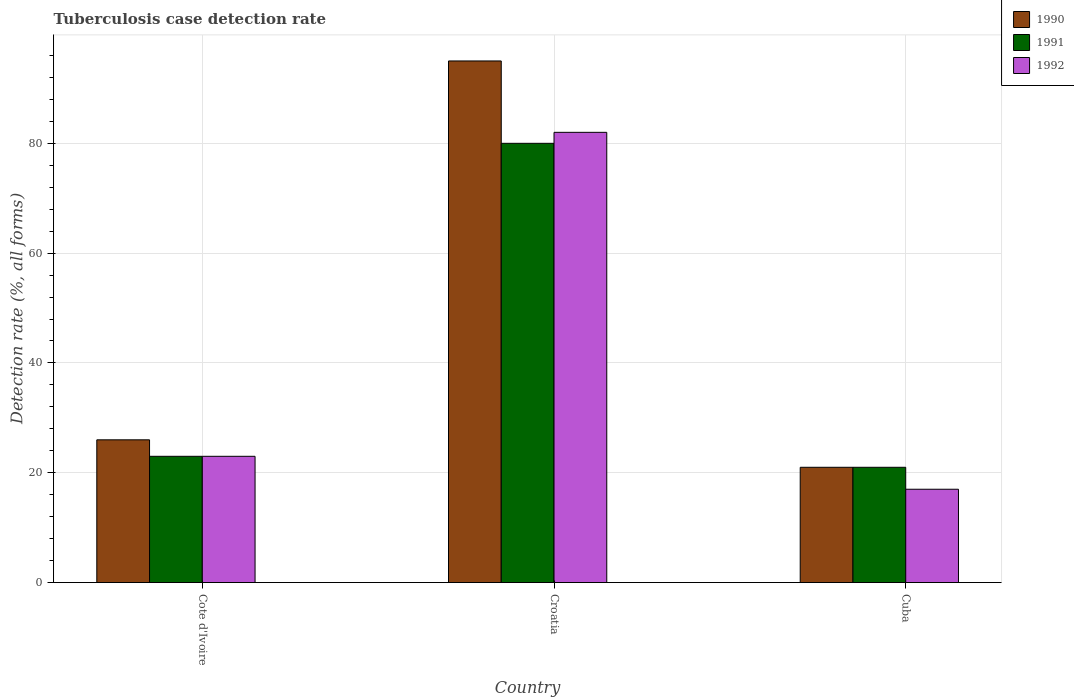How many different coloured bars are there?
Give a very brief answer. 3. How many groups of bars are there?
Your response must be concise. 3. Are the number of bars per tick equal to the number of legend labels?
Keep it short and to the point. Yes. How many bars are there on the 3rd tick from the right?
Ensure brevity in your answer.  3. What is the label of the 3rd group of bars from the left?
Make the answer very short. Cuba. Across all countries, what is the maximum tuberculosis case detection rate in in 1990?
Provide a short and direct response. 95. Across all countries, what is the minimum tuberculosis case detection rate in in 1990?
Offer a terse response. 21. In which country was the tuberculosis case detection rate in in 1992 maximum?
Give a very brief answer. Croatia. In which country was the tuberculosis case detection rate in in 1990 minimum?
Ensure brevity in your answer.  Cuba. What is the total tuberculosis case detection rate in in 1992 in the graph?
Give a very brief answer. 122. What is the average tuberculosis case detection rate in in 1992 per country?
Ensure brevity in your answer.  40.67. What is the difference between the tuberculosis case detection rate in of/in 1990 and tuberculosis case detection rate in of/in 1992 in Cuba?
Give a very brief answer. 4. In how many countries, is the tuberculosis case detection rate in in 1992 greater than 68 %?
Make the answer very short. 1. What is the ratio of the tuberculosis case detection rate in in 1991 in Cote d'Ivoire to that in Cuba?
Make the answer very short. 1.1. Is the tuberculosis case detection rate in in 1990 in Cote d'Ivoire less than that in Cuba?
Ensure brevity in your answer.  No. Is the difference between the tuberculosis case detection rate in in 1990 in Cote d'Ivoire and Cuba greater than the difference between the tuberculosis case detection rate in in 1992 in Cote d'Ivoire and Cuba?
Your answer should be very brief. No. What is the difference between the highest and the second highest tuberculosis case detection rate in in 1991?
Offer a very short reply. 59. In how many countries, is the tuberculosis case detection rate in in 1991 greater than the average tuberculosis case detection rate in in 1991 taken over all countries?
Give a very brief answer. 1. What does the 1st bar from the left in Cuba represents?
Keep it short and to the point. 1990. Are all the bars in the graph horizontal?
Provide a short and direct response. No. Does the graph contain any zero values?
Give a very brief answer. No. How many legend labels are there?
Offer a very short reply. 3. What is the title of the graph?
Your answer should be compact. Tuberculosis case detection rate. Does "1970" appear as one of the legend labels in the graph?
Offer a terse response. No. What is the label or title of the X-axis?
Make the answer very short. Country. What is the label or title of the Y-axis?
Keep it short and to the point. Detection rate (%, all forms). What is the Detection rate (%, all forms) in 1990 in Croatia?
Your answer should be compact. 95. What is the Detection rate (%, all forms) of 1992 in Croatia?
Your answer should be compact. 82. What is the Detection rate (%, all forms) in 1990 in Cuba?
Ensure brevity in your answer.  21. What is the Detection rate (%, all forms) in 1992 in Cuba?
Offer a terse response. 17. Across all countries, what is the maximum Detection rate (%, all forms) of 1990?
Make the answer very short. 95. Across all countries, what is the minimum Detection rate (%, all forms) in 1990?
Provide a succinct answer. 21. Across all countries, what is the minimum Detection rate (%, all forms) in 1991?
Ensure brevity in your answer.  21. What is the total Detection rate (%, all forms) in 1990 in the graph?
Your response must be concise. 142. What is the total Detection rate (%, all forms) of 1991 in the graph?
Make the answer very short. 124. What is the total Detection rate (%, all forms) in 1992 in the graph?
Your answer should be compact. 122. What is the difference between the Detection rate (%, all forms) in 1990 in Cote d'Ivoire and that in Croatia?
Your answer should be very brief. -69. What is the difference between the Detection rate (%, all forms) of 1991 in Cote d'Ivoire and that in Croatia?
Provide a short and direct response. -57. What is the difference between the Detection rate (%, all forms) in 1992 in Cote d'Ivoire and that in Croatia?
Your response must be concise. -59. What is the difference between the Detection rate (%, all forms) of 1992 in Croatia and that in Cuba?
Your answer should be very brief. 65. What is the difference between the Detection rate (%, all forms) of 1990 in Cote d'Ivoire and the Detection rate (%, all forms) of 1991 in Croatia?
Offer a very short reply. -54. What is the difference between the Detection rate (%, all forms) of 1990 in Cote d'Ivoire and the Detection rate (%, all forms) of 1992 in Croatia?
Provide a short and direct response. -56. What is the difference between the Detection rate (%, all forms) in 1991 in Cote d'Ivoire and the Detection rate (%, all forms) in 1992 in Croatia?
Your response must be concise. -59. What is the difference between the Detection rate (%, all forms) in 1990 in Cote d'Ivoire and the Detection rate (%, all forms) in 1991 in Cuba?
Give a very brief answer. 5. What is the difference between the Detection rate (%, all forms) of 1991 in Cote d'Ivoire and the Detection rate (%, all forms) of 1992 in Cuba?
Offer a very short reply. 6. What is the difference between the Detection rate (%, all forms) of 1990 in Croatia and the Detection rate (%, all forms) of 1991 in Cuba?
Your response must be concise. 74. What is the difference between the Detection rate (%, all forms) of 1990 in Croatia and the Detection rate (%, all forms) of 1992 in Cuba?
Make the answer very short. 78. What is the difference between the Detection rate (%, all forms) in 1991 in Croatia and the Detection rate (%, all forms) in 1992 in Cuba?
Provide a short and direct response. 63. What is the average Detection rate (%, all forms) of 1990 per country?
Provide a succinct answer. 47.33. What is the average Detection rate (%, all forms) of 1991 per country?
Provide a short and direct response. 41.33. What is the average Detection rate (%, all forms) of 1992 per country?
Offer a terse response. 40.67. What is the difference between the Detection rate (%, all forms) of 1990 and Detection rate (%, all forms) of 1991 in Cote d'Ivoire?
Give a very brief answer. 3. What is the difference between the Detection rate (%, all forms) in 1990 and Detection rate (%, all forms) in 1992 in Cote d'Ivoire?
Offer a terse response. 3. What is the difference between the Detection rate (%, all forms) of 1990 and Detection rate (%, all forms) of 1992 in Cuba?
Make the answer very short. 4. What is the difference between the Detection rate (%, all forms) of 1991 and Detection rate (%, all forms) of 1992 in Cuba?
Keep it short and to the point. 4. What is the ratio of the Detection rate (%, all forms) of 1990 in Cote d'Ivoire to that in Croatia?
Provide a short and direct response. 0.27. What is the ratio of the Detection rate (%, all forms) of 1991 in Cote d'Ivoire to that in Croatia?
Give a very brief answer. 0.29. What is the ratio of the Detection rate (%, all forms) of 1992 in Cote d'Ivoire to that in Croatia?
Provide a succinct answer. 0.28. What is the ratio of the Detection rate (%, all forms) in 1990 in Cote d'Ivoire to that in Cuba?
Your answer should be very brief. 1.24. What is the ratio of the Detection rate (%, all forms) in 1991 in Cote d'Ivoire to that in Cuba?
Ensure brevity in your answer.  1.1. What is the ratio of the Detection rate (%, all forms) of 1992 in Cote d'Ivoire to that in Cuba?
Give a very brief answer. 1.35. What is the ratio of the Detection rate (%, all forms) of 1990 in Croatia to that in Cuba?
Your answer should be very brief. 4.52. What is the ratio of the Detection rate (%, all forms) in 1991 in Croatia to that in Cuba?
Your answer should be very brief. 3.81. What is the ratio of the Detection rate (%, all forms) of 1992 in Croatia to that in Cuba?
Give a very brief answer. 4.82. What is the difference between the highest and the second highest Detection rate (%, all forms) in 1990?
Give a very brief answer. 69. What is the difference between the highest and the second highest Detection rate (%, all forms) of 1992?
Ensure brevity in your answer.  59. What is the difference between the highest and the lowest Detection rate (%, all forms) in 1991?
Ensure brevity in your answer.  59. What is the difference between the highest and the lowest Detection rate (%, all forms) in 1992?
Your answer should be very brief. 65. 